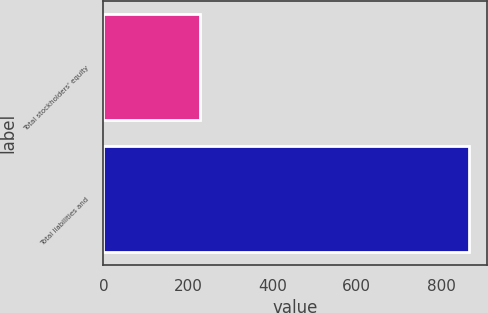Convert chart to OTSL. <chart><loc_0><loc_0><loc_500><loc_500><bar_chart><fcel>Total stockholders' equity<fcel>Total liabilities and<nl><fcel>228.6<fcel>865.3<nl></chart> 